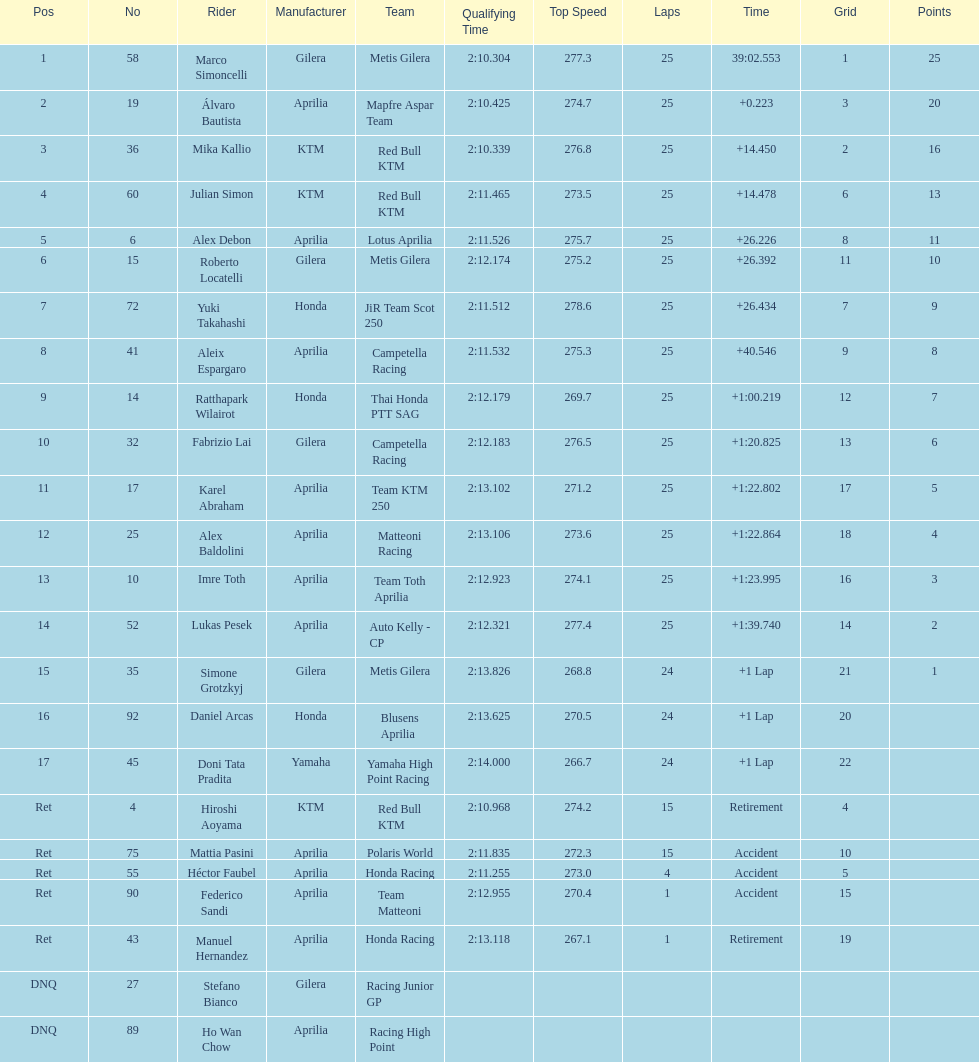The next rider from italy aside from winner marco simoncelli was Roberto Locatelli. I'm looking to parse the entire table for insights. Could you assist me with that? {'header': ['Pos', 'No', 'Rider', 'Manufacturer', 'Team', 'Qualifying Time', 'Top Speed', 'Laps', 'Time', 'Grid', 'Points'], 'rows': [['1', '58', 'Marco Simoncelli', 'Gilera', 'Metis Gilera', '2:10.304', '277.3', '25', '39:02.553', '1', '25'], ['2', '19', 'Álvaro Bautista', 'Aprilia', 'Mapfre Aspar Team', '2:10.425', '274.7', '25', '+0.223', '3', '20'], ['3', '36', 'Mika Kallio', 'KTM', 'Red Bull KTM', '2:10.339', '276.8', '25', '+14.450', '2', '16'], ['4', '60', 'Julian Simon', 'KTM', 'Red Bull KTM', '2:11.465', '273.5', '25', '+14.478', '6', '13'], ['5', '6', 'Alex Debon', 'Aprilia', 'Lotus Aprilia', '2:11.526', '275.7', '25', '+26.226', '8', '11'], ['6', '15', 'Roberto Locatelli', 'Gilera', 'Metis Gilera', '2:12.174', '275.2', '25', '+26.392', '11', '10'], ['7', '72', 'Yuki Takahashi', 'Honda', 'JiR Team Scot 250', '2:11.512', '278.6', '25', '+26.434', '7', '9'], ['8', '41', 'Aleix Espargaro', 'Aprilia', 'Campetella Racing', '2:11.532', '275.3', '25', '+40.546', '9', '8'], ['9', '14', 'Ratthapark Wilairot', 'Honda', 'Thai Honda PTT SAG', '2:12.179', '269.7', '25', '+1:00.219', '12', '7'], ['10', '32', 'Fabrizio Lai', 'Gilera', 'Campetella Racing', '2:12.183', '276.5', '25', '+1:20.825', '13', '6'], ['11', '17', 'Karel Abraham', 'Aprilia', 'Team KTM 250', '2:13.102', '271.2', '25', '+1:22.802', '17', '5'], ['12', '25', 'Alex Baldolini', 'Aprilia', 'Matteoni Racing', '2:13.106', '273.6', '25', '+1:22.864', '18', '4'], ['13', '10', 'Imre Toth', 'Aprilia', 'Team Toth Aprilia', '2:12.923', '274.1', '25', '+1:23.995', '16', '3'], ['14', '52', 'Lukas Pesek', 'Aprilia', 'Auto Kelly - CP', '2:12.321', '277.4', '25', '+1:39.740', '14', '2'], ['15', '35', 'Simone Grotzkyj', 'Gilera', 'Metis Gilera', '2:13.826', '268.8', '24', '+1 Lap', '21', '1'], ['16', '92', 'Daniel Arcas', 'Honda', 'Blusens Aprilia', '2:13.625', '270.5', '24', '+1 Lap', '20', ''], ['17', '45', 'Doni Tata Pradita', 'Yamaha', 'Yamaha High Point Racing', '2:14.000', '266.7', '24', '+1 Lap', '22', ''], ['Ret', '4', 'Hiroshi Aoyama', 'KTM', 'Red Bull KTM', '2:10.968', '274.2', '15', 'Retirement', '4', ''], ['Ret', '75', 'Mattia Pasini', 'Aprilia', 'Polaris World', '2:11.835', '272.3', '15', 'Accident', '10', ''], ['Ret', '55', 'Héctor Faubel', 'Aprilia', 'Honda Racing', '2:11.255', '273.0', '4', 'Accident', '5', ''], ['Ret', '90', 'Federico Sandi', 'Aprilia', 'Team Matteoni', '2:12.955', '270.4', '1', 'Accident', '15', ''], ['Ret', '43', 'Manuel Hernandez', 'Aprilia', 'Honda Racing', '2:13.118', '267.1', '1', 'Retirement', '19', ''], ['DNQ', '27', 'Stefano Bianco', 'Gilera', 'Racing Junior GP', '', '', '', '', '', ''], ['DNQ', '89', 'Ho Wan Chow', 'Aprilia', 'Racing High Point', '', '', '', '', '', '']]} 